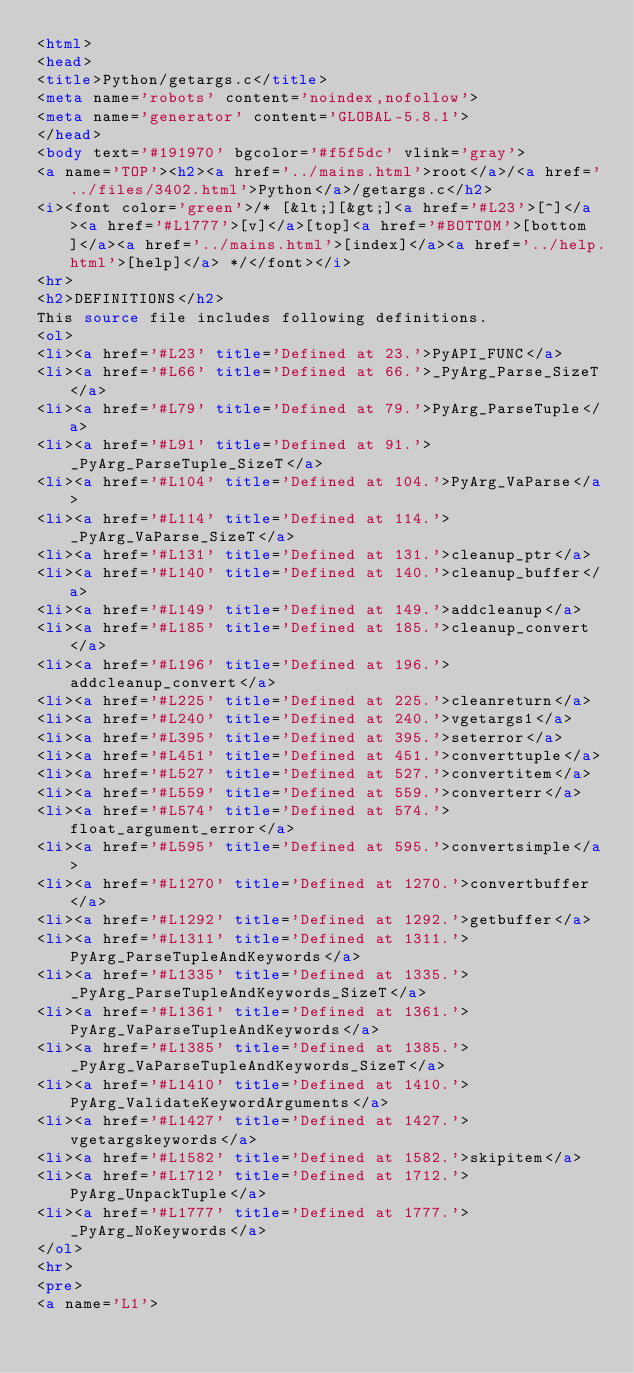<code> <loc_0><loc_0><loc_500><loc_500><_HTML_><html>
<head>
<title>Python/getargs.c</title>
<meta name='robots' content='noindex,nofollow'>
<meta name='generator' content='GLOBAL-5.8.1'>
</head>
<body text='#191970' bgcolor='#f5f5dc' vlink='gray'>
<a name='TOP'><h2><a href='../mains.html'>root</a>/<a href='../files/3402.html'>Python</a>/getargs.c</h2>
<i><font color='green'>/* [&lt;][&gt;]<a href='#L23'>[^]</a><a href='#L1777'>[v]</a>[top]<a href='#BOTTOM'>[bottom]</a><a href='../mains.html'>[index]</a><a href='../help.html'>[help]</a> */</font></i>
<hr>
<h2>DEFINITIONS</h2>
This source file includes following definitions.
<ol>
<li><a href='#L23' title='Defined at 23.'>PyAPI_FUNC</a>
<li><a href='#L66' title='Defined at 66.'>_PyArg_Parse_SizeT</a>
<li><a href='#L79' title='Defined at 79.'>PyArg_ParseTuple</a>
<li><a href='#L91' title='Defined at 91.'>_PyArg_ParseTuple_SizeT</a>
<li><a href='#L104' title='Defined at 104.'>PyArg_VaParse</a>
<li><a href='#L114' title='Defined at 114.'>_PyArg_VaParse_SizeT</a>
<li><a href='#L131' title='Defined at 131.'>cleanup_ptr</a>
<li><a href='#L140' title='Defined at 140.'>cleanup_buffer</a>
<li><a href='#L149' title='Defined at 149.'>addcleanup</a>
<li><a href='#L185' title='Defined at 185.'>cleanup_convert</a>
<li><a href='#L196' title='Defined at 196.'>addcleanup_convert</a>
<li><a href='#L225' title='Defined at 225.'>cleanreturn</a>
<li><a href='#L240' title='Defined at 240.'>vgetargs1</a>
<li><a href='#L395' title='Defined at 395.'>seterror</a>
<li><a href='#L451' title='Defined at 451.'>converttuple</a>
<li><a href='#L527' title='Defined at 527.'>convertitem</a>
<li><a href='#L559' title='Defined at 559.'>converterr</a>
<li><a href='#L574' title='Defined at 574.'>float_argument_error</a>
<li><a href='#L595' title='Defined at 595.'>convertsimple</a>
<li><a href='#L1270' title='Defined at 1270.'>convertbuffer</a>
<li><a href='#L1292' title='Defined at 1292.'>getbuffer</a>
<li><a href='#L1311' title='Defined at 1311.'>PyArg_ParseTupleAndKeywords</a>
<li><a href='#L1335' title='Defined at 1335.'>_PyArg_ParseTupleAndKeywords_SizeT</a>
<li><a href='#L1361' title='Defined at 1361.'>PyArg_VaParseTupleAndKeywords</a>
<li><a href='#L1385' title='Defined at 1385.'>_PyArg_VaParseTupleAndKeywords_SizeT</a>
<li><a href='#L1410' title='Defined at 1410.'>PyArg_ValidateKeywordArguments</a>
<li><a href='#L1427' title='Defined at 1427.'>vgetargskeywords</a>
<li><a href='#L1582' title='Defined at 1582.'>skipitem</a>
<li><a href='#L1712' title='Defined at 1712.'>PyArg_UnpackTuple</a>
<li><a href='#L1777' title='Defined at 1777.'>_PyArg_NoKeywords</a>
</ol>
<hr>
<pre>
<a name='L1'></code> 